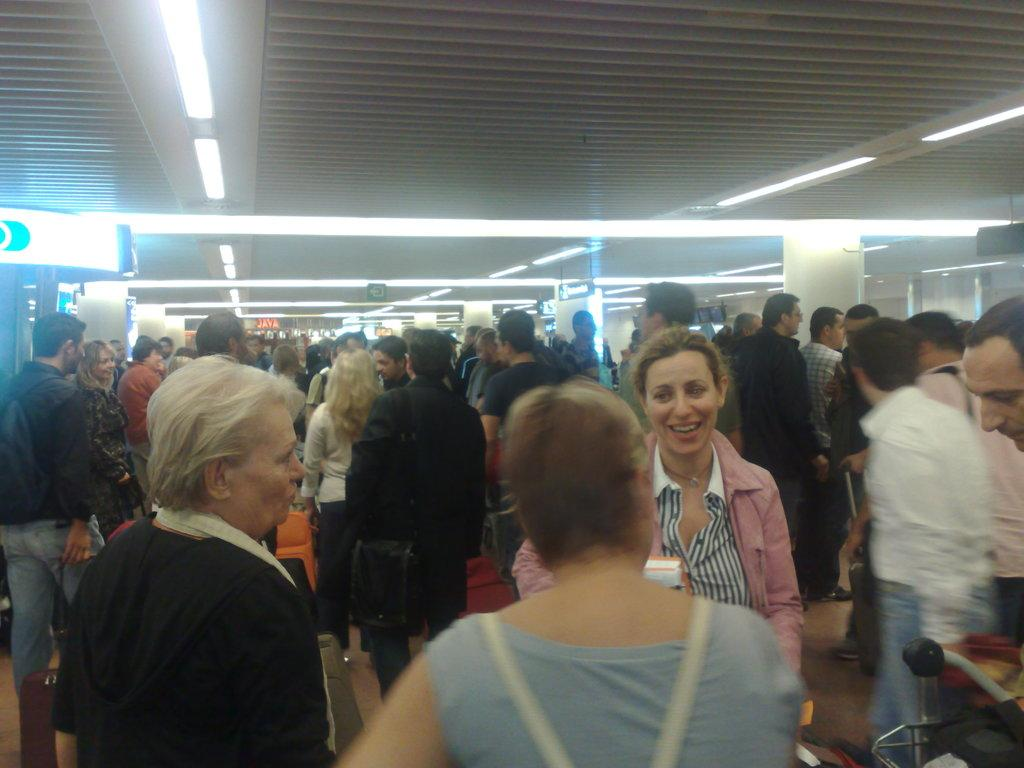Who is present in the image? There is a woman in the image. What is the woman doing in the image? The woman is smiling in the image. Who else is present in the image besides the woman? There is a group of people in the image. What can be seen in the background of the image? Ceiling lights are visible in the image. What type of baseball is the woman holding in the image? There is no baseball present in the image. What word is written on the woman's shirt in the image? We cannot determine any words on the woman's shirt from the image. What muscle is the woman flexing in the image? There is no indication of the woman flexing any muscles in the image. 